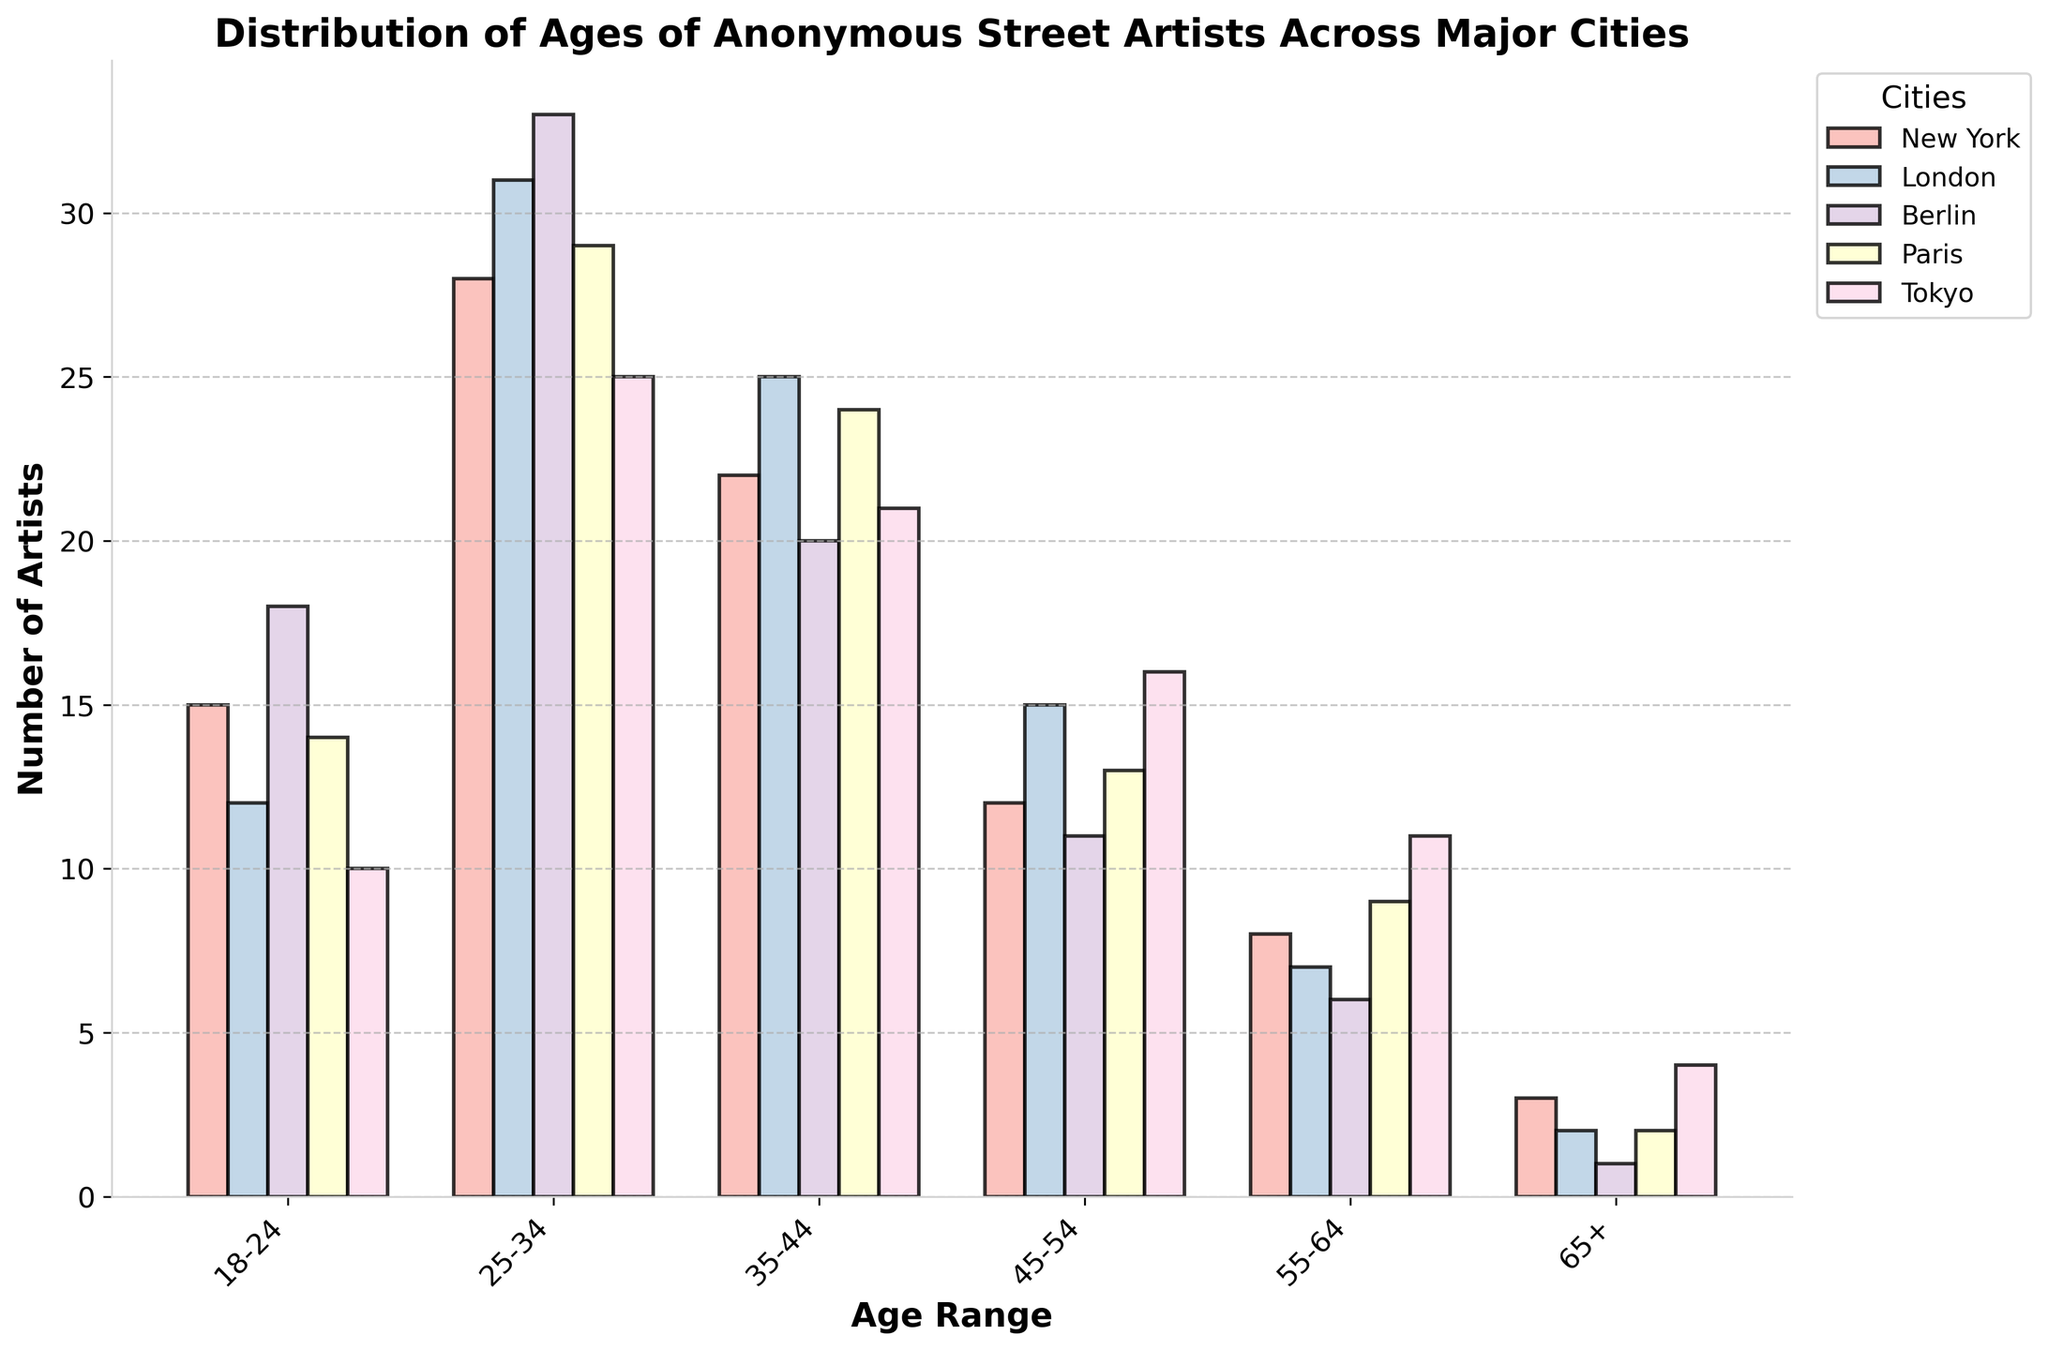What is the title of the histogram? The title is written at the top of the histogram and provides an overview of what the plot represents. Read the title displayed at the top of the figure.
Answer: Distribution of Ages of Anonymous Street Artists Across Major Cities How many artists are aged 25-34 in Berlin? Look for the bar corresponding to Berlin in the 25-34 age range and read its height or label.
Answer: 33 Which city has the highest number of artists in the 45-54 age range? Compare the heights of the bars for all cities in the 45-54 age range and identify which one is the tallest.
Answer: Tokyo Which age range has an equal number of artists in New York and Paris? Compare the number of artists in New York and Paris for each age range, and look for the range(s) where the numbers match.
Answer: 18-24 In which age range does London have the highest number of street artists? Compare the heights of London's bars across all age ranges to identify which one is the tallest.
Answer: 25-34 Which age range shows a declining trend in the number of artists as age increases in Tokyo? Compare the heights of the bars for Tokyo across adjacent age ranges to see if there is a consistent decline. Check from 18-24 to 25-34, 25-34 to 35-44, and so on.
Answer: 25-34 to 65+ Which city has the most artists aged 18-24 and the least artists aged 55-64? Identify the city with the highest bar in the 18-24 range and the city with the lowest bar in the 55-64 range.
Answer: Berlin (18) for 18-24 and Berlin (6) for 55-64 